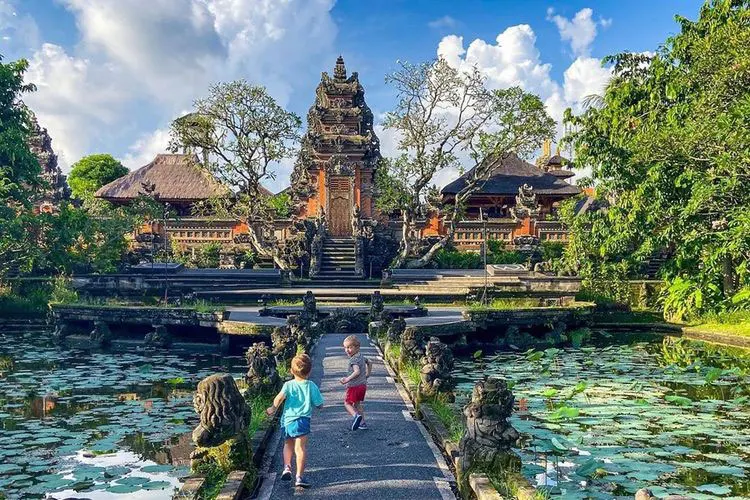What stories could the carvings on the palace tell? The carvings on the palace are likely to be steeped in the myths and legends of Balinese culture. They may depict tales of gods and goddesses, heroic battles, and the daily lives of ancient people. These intricate designs serve as a visual narrative, preserving the folklore and traditions of the region. Can you describe in detail one of the statues in front of the palace? Sure! One of the statues in front of the palace appears to be a guardian figure, perhaps representing a traditional Balinese deity or mythological creature. The statue is finely detailed, with ornate patterns and symbolic motifs adorning its body. Its expression is stern yet serene, embodying the protective qualities it is meant to invoke. The craftsmanship reflects the artistic dedication of the carvers, and its placement suggests it plays a role in warding off negative influences, while welcoming visitors to the palace. 